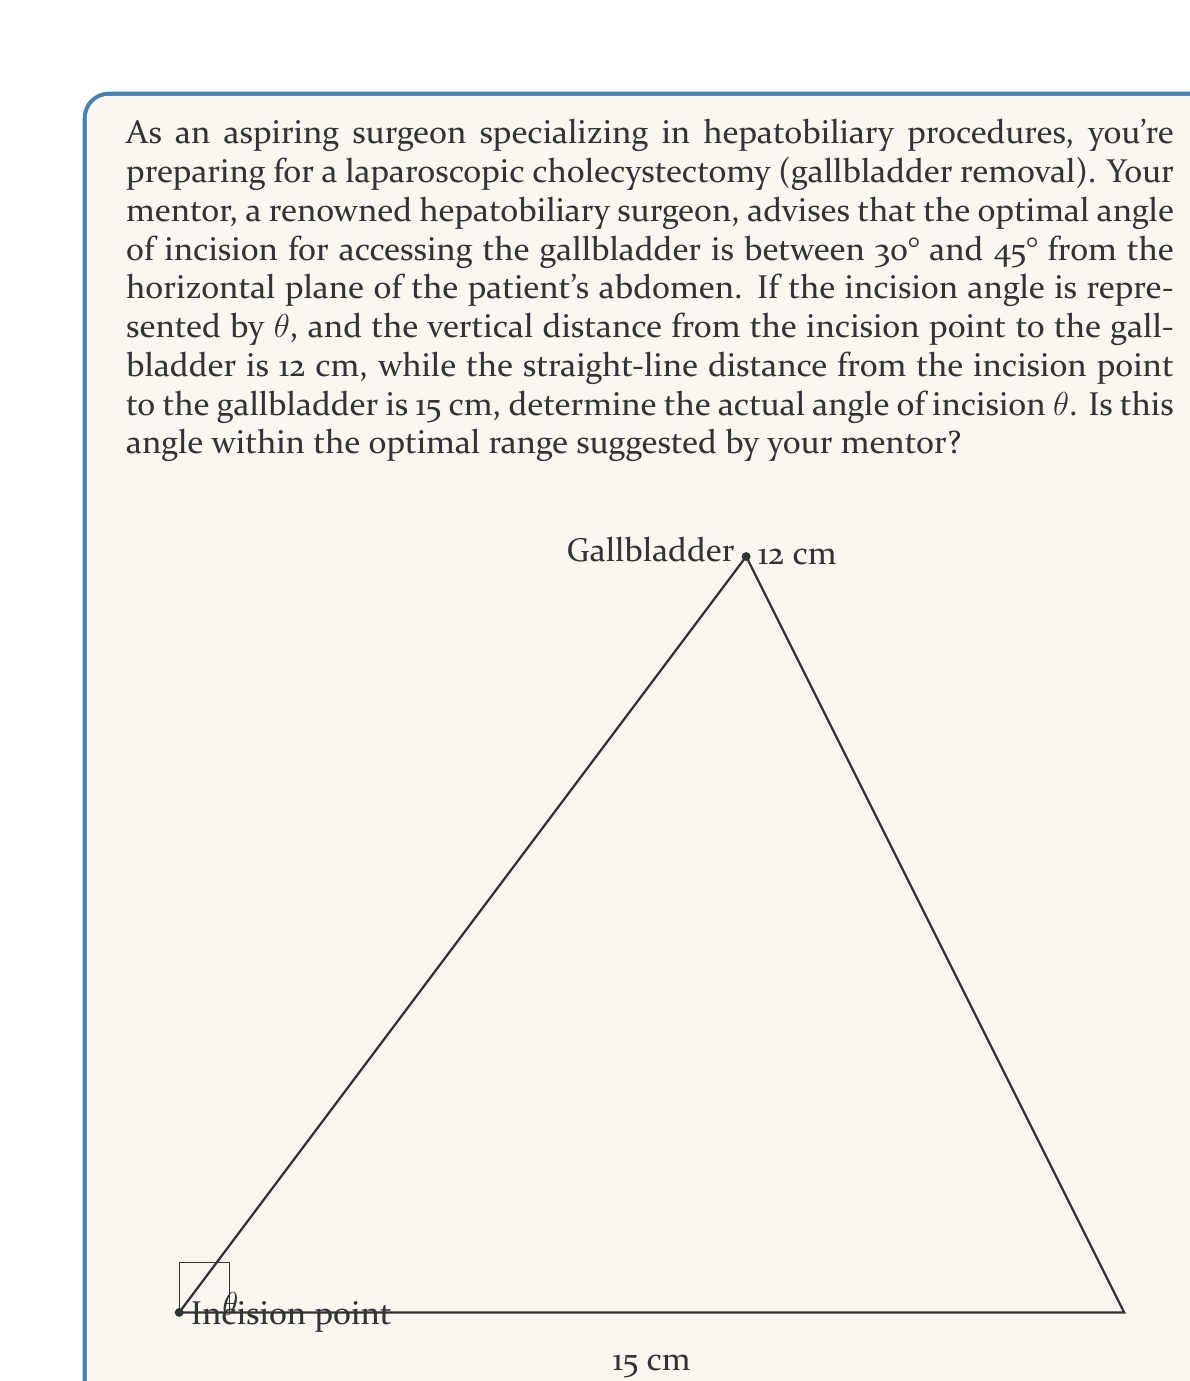Help me with this question. Let's approach this step-by-step using trigonometry:

1) The scenario presents a right-angled triangle, where:
   - The vertical side (opposite to $\theta$) is 12 cm
   - The hypotenuse is 15 cm
   - We need to find $\theta$

2) In a right-angled triangle, we can use the sine function to find $\theta$:

   $$\sin \theta = \frac{\text{opposite}}{\text{hypotenuse}} = \frac{12}{15}$$

3) To find $\theta$, we need to take the inverse sine (arcsin or $\sin^{-1}$):

   $$\theta = \sin^{-1}\left(\frac{12}{15}\right)$$

4) Using a calculator or computer:

   $$\theta \approx 53.13°$$

5) To verify if this is within the optimal range (30° to 45°):
   53.13° > 45°, so it is not within the suggested optimal range.

6) We can also calculate the exact angle using the following:

   $$\theta = \sin^{-1}\left(\frac{4}{5}\right) = \arcsin(0.8)$$

This gives us the exact value, which is approximately 53.13°.
Answer: The angle of incision $\theta$ is $\sin^{-1}\left(\frac{4}{5}\right)$, or approximately 53.13°. This angle is not within the optimal range of 30° to 45° suggested by the mentor. 